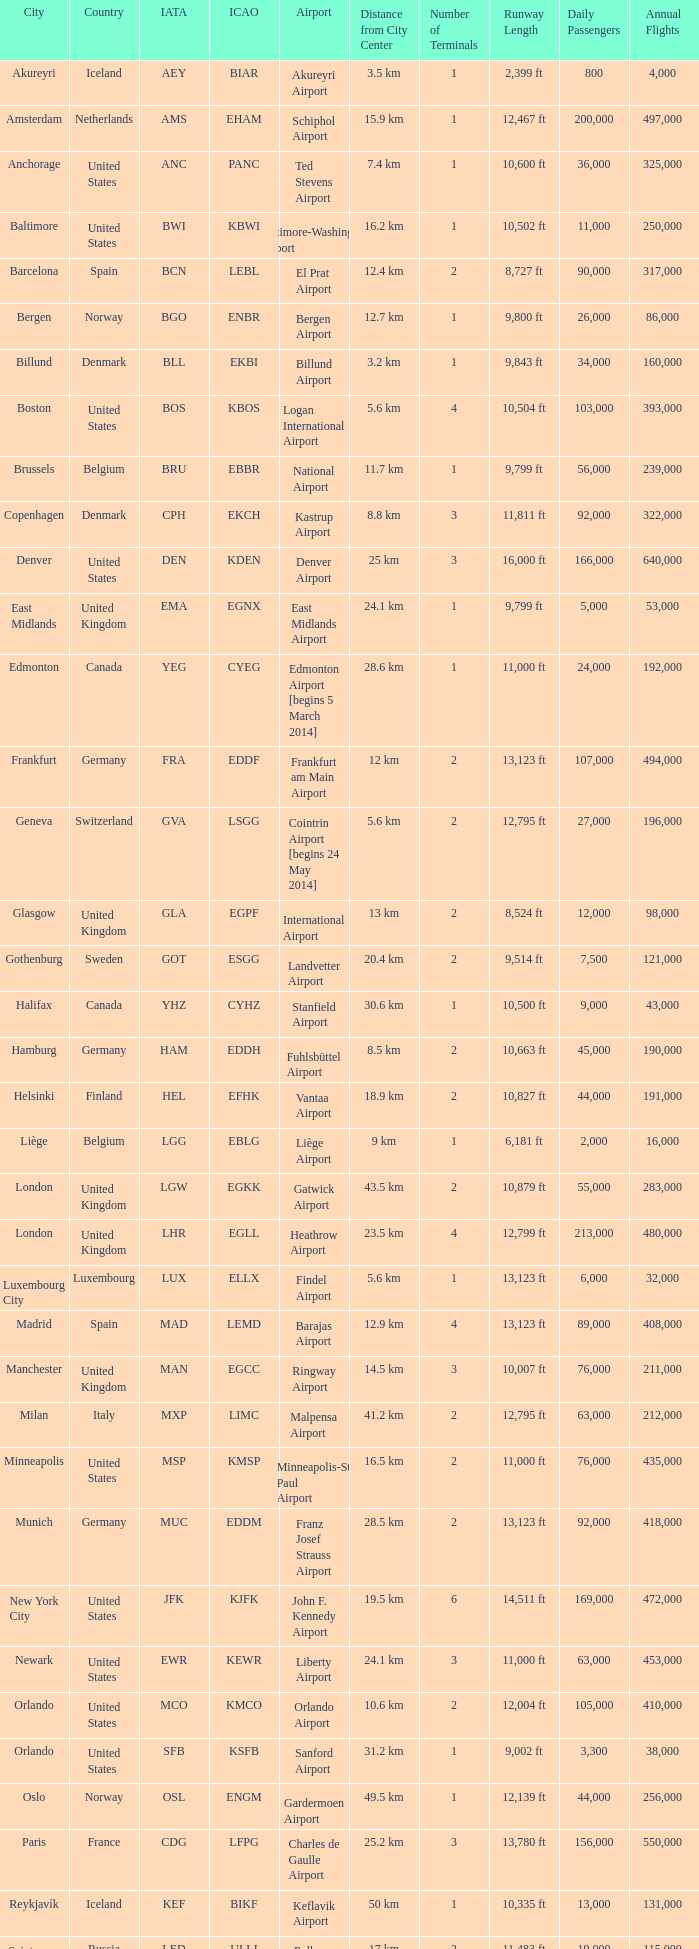What is akureyri's iata identifier? AEY. 